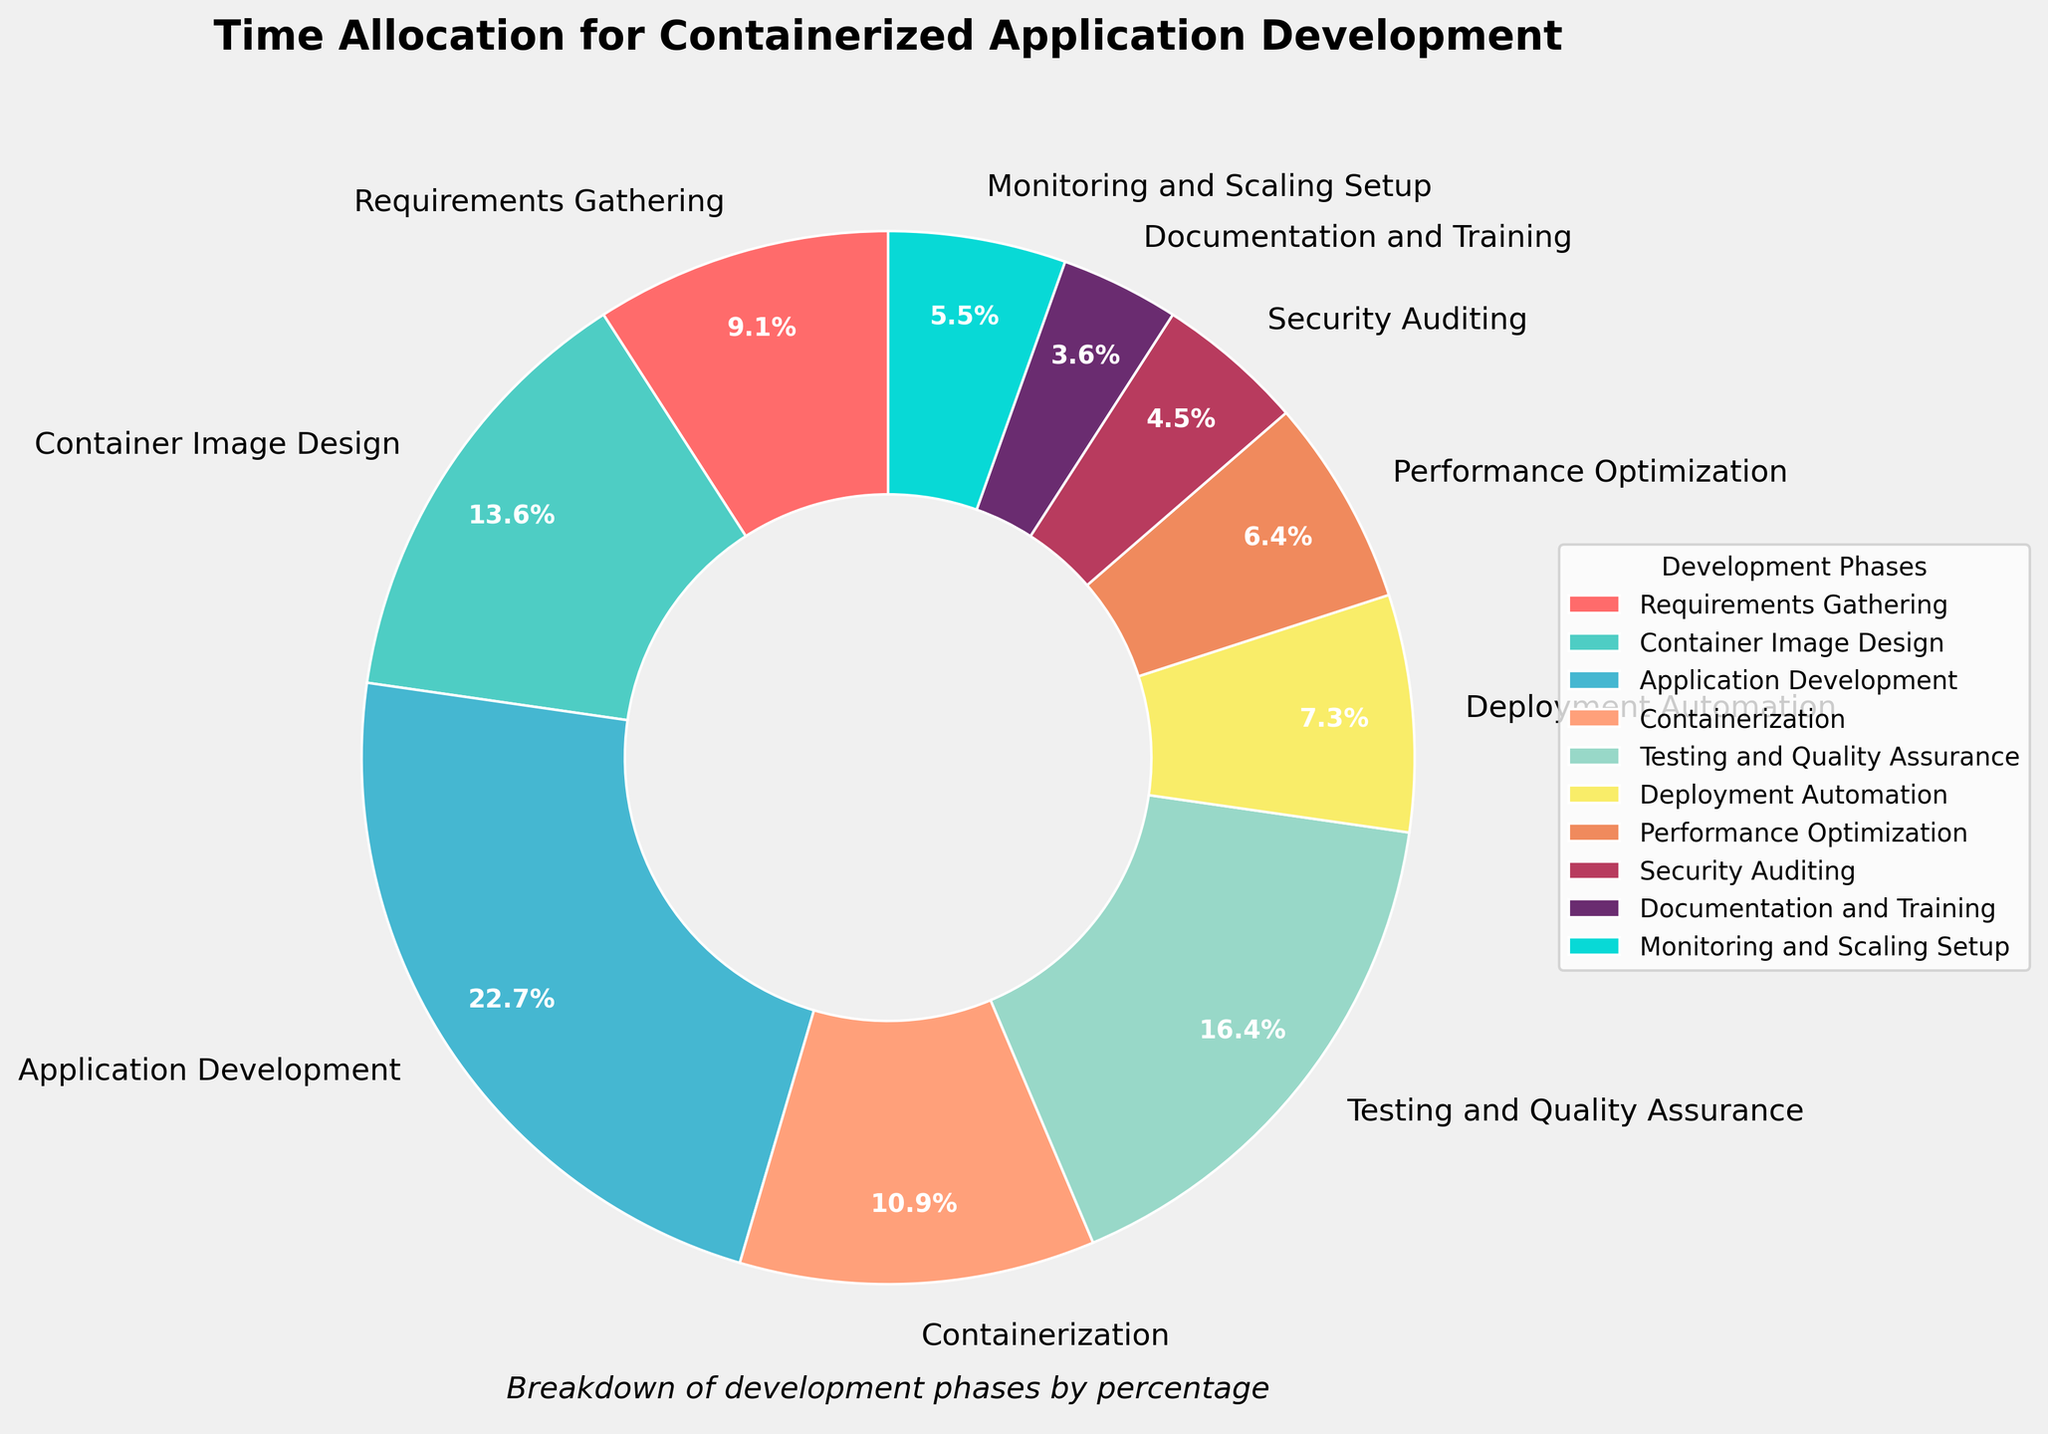1. What phase occupies the largest percentage? The largest wedge in the pie chart would indicate the phase with the highest percentage. In this case, "Application Development" has the largest wedge.
Answer: Application Development 2. How does the time allocation for "Testing and Quality Assurance" compare to "Security Auditing"? Check the percentages for both phases from the pie chart. "Testing and Quality Assurance" is at 18%, while "Security Auditing" is at 5%. 18% is greater than 5%.
Answer: Testing and Quality Assurance is greater 3. Which phase has a smaller percentage: "Documentation and Training" or "Performance Optimization"? Both wedges should be compared directly on the pie chart. "Documentation and Training" is at 4%, while "Performance Optimization" is at 7%.
Answer: Documentation and Training 4. What is the combined percentage of time spent on "Containerization" and "Deployment Automation"? Sum the percentages from the pie chart: Containerization (12%) + Deployment Automation (8%) = 20%
Answer: 20% 5. Which segment of the pie chart is represented in green, and what is its percentage? Look for the green segment in the pie chart. In this case, it corresponds to "Testing and Quality Assurance" with a percentage of 18%.
Answer: Testing and Quality Assurance, 18% 6. Is the percentage of time spent on "Performance Optimization" greater, lesser, or equal to the time spent on "Monitoring and Scaling Setup"? Compare the percentages of the two phases: Performance Optimization (7%) vs. Monitoring and Scaling Setup (6%). 7% is slightly greater than 6%.
Answer: Greater 7. What is the difference in time allocation between "Container Image Design" and "Monitoring and Scaling Setup"? Subtract the percentage of "Monitoring and Scaling Setup" from "Container Image Design": 15% - 6% = 9%
Answer: 9% 8. Which two consecutive phases combined constitute 40% of time allocation? Identify two consecutive phases whose summed percentages equal 40%. In this case, "Application Development" (25%) and "Containerization" (12%) combined make 37%, which isn't correct. However, "Application Development" (25%) and "Testing and Quality Assurance" (18%) combined make 43%, which also isn't correct. Upon further inspection, "Container Image Design" (15%) and "Application Development" (25%) combined equal 40%.
Answer: Container Image Design and Application Development 9. What phase is represented by the red wedge in the pie chart? Locate the red wedge in the pie chart, which represents "Requirements Gathering".
Answer: Requirements Gathering 10. What is the average percentage of time allocation for "Container Image Design", "Containerization", and "Deployment Automation"? Sum the percentages of these phases and divide by 3: (15% + 12% + 8%) / 3 = 35% / 3 ≈ 11.67%
Answer: 11.67% 